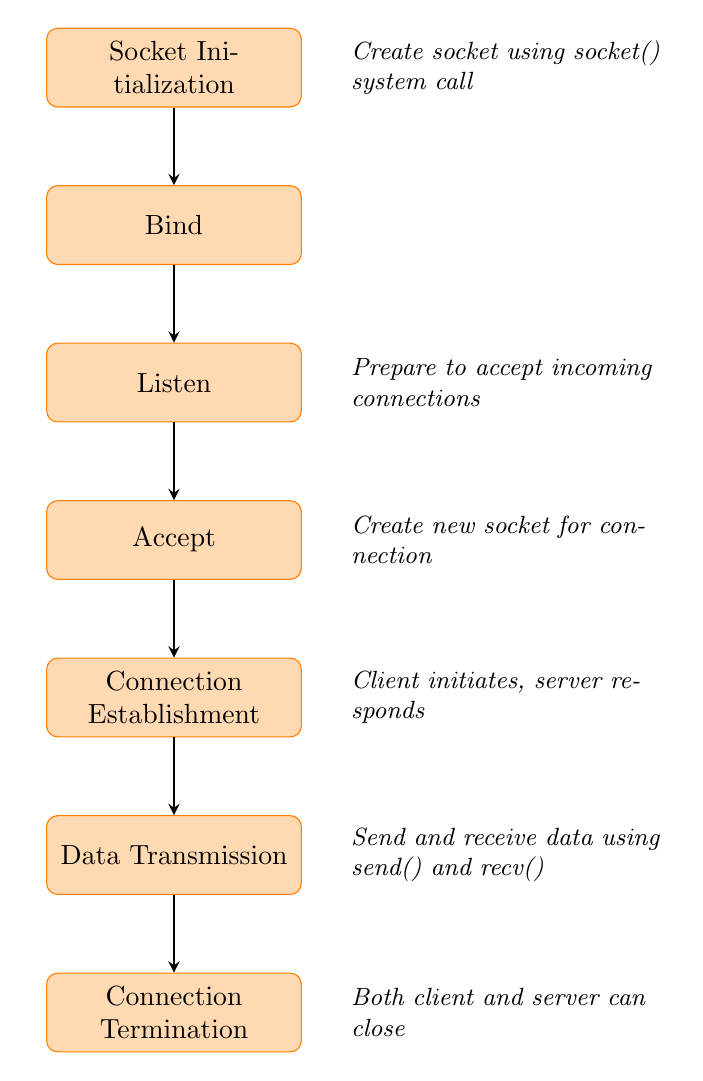What is the first step in the socket connection process? The first step indicated in the diagram is "Socket Initialization," which is where a socket is created using the socket() system call.
Answer: Socket Initialization How many nodes are there in the flow chart? The flow chart contains a total of seven nodes representing different actions within the socket connection process.
Answer: Seven What follows the "Listen" step in the flow chart? The step that comes after "Listen" is "Accept," indicating the process of accepting an incoming connection.
Answer: Accept What system call is used to send and receive data? The diagram states that data is sent and received using the send() and recv() system calls.
Answer: send() and recv() How is a new socket created during the process? A new socket is created during the "Accept" step when the server accepts an incoming connection, resulting in the generation of a new socket for that connection.
Answer: Create new socket for connection What is the final step in the socket connection process? The last step in the diagram is "Connection Termination," which involves closing the connection using the close() system call.
Answer: Connection Termination What does the "Connection Establishment" step signify? The "Connection Establishment" step signifies that the client initiates the connection using the connect() system call, and the server responds, completing the three-way handshake necessary for establishing a socket connection.
Answer: Client initiates, server responds What is the role of the "Listen" step? The "Listen" step prepares the socket to accept incoming connection requests, indicating that the server is ready to handle any client requests.
Answer: Prepare to accept incoming connections What happens during the "Data Transmission" stage? In the "Data Transmission" stage, data is actively sent and received between the client and server using designated system calls, which facilitate communication over the established connection.
Answer: Send and receive data using send() and recv() 